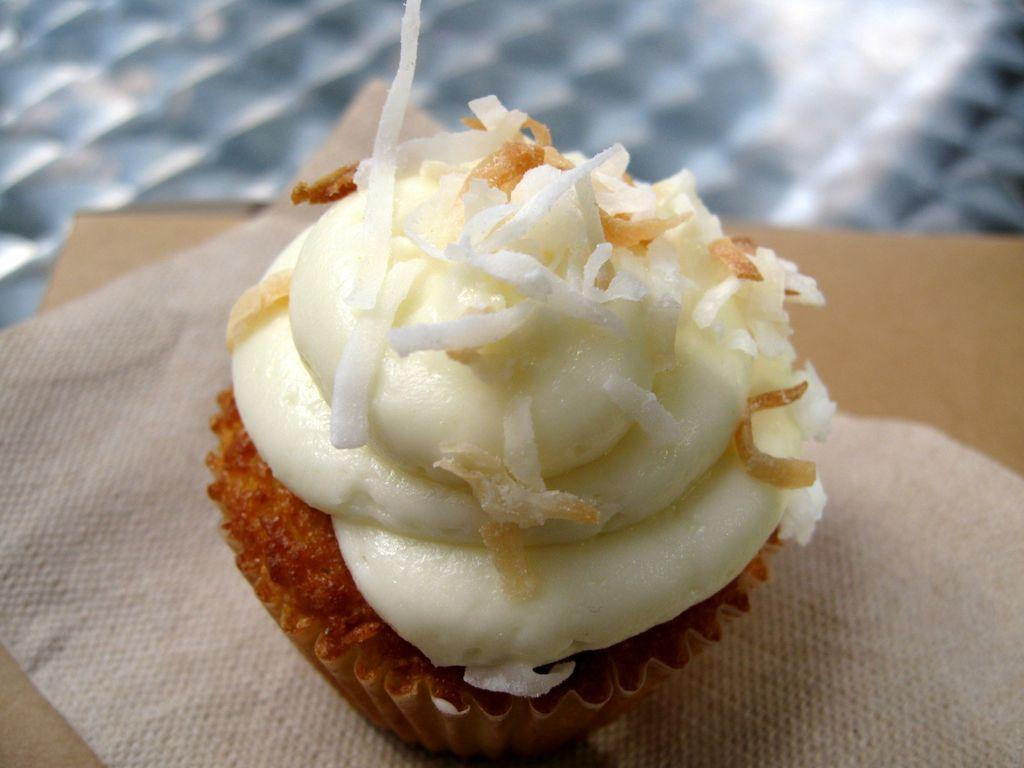What type of food is visible in the image? There is a cupcake in the image. What is the cupcake placed on? The cupcake is on a tissue. What is the tissue placed on? The tissue is on an object. How would you describe the background of the image? The background of the image is blurred. What type of protest is happening in the background of the image? There is no protest visible in the image; the background is blurred. Who is the writer of the playground depicted in the image? There is no playground or writer present in the image; it features a cupcake on a tissue. 